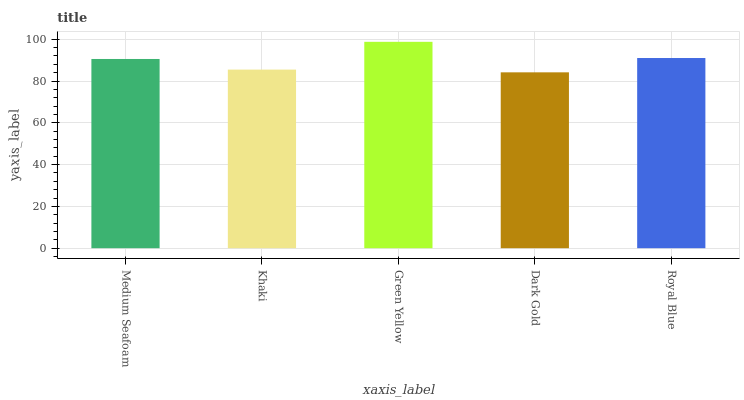Is Dark Gold the minimum?
Answer yes or no. Yes. Is Green Yellow the maximum?
Answer yes or no. Yes. Is Khaki the minimum?
Answer yes or no. No. Is Khaki the maximum?
Answer yes or no. No. Is Medium Seafoam greater than Khaki?
Answer yes or no. Yes. Is Khaki less than Medium Seafoam?
Answer yes or no. Yes. Is Khaki greater than Medium Seafoam?
Answer yes or no. No. Is Medium Seafoam less than Khaki?
Answer yes or no. No. Is Medium Seafoam the high median?
Answer yes or no. Yes. Is Medium Seafoam the low median?
Answer yes or no. Yes. Is Royal Blue the high median?
Answer yes or no. No. Is Khaki the low median?
Answer yes or no. No. 